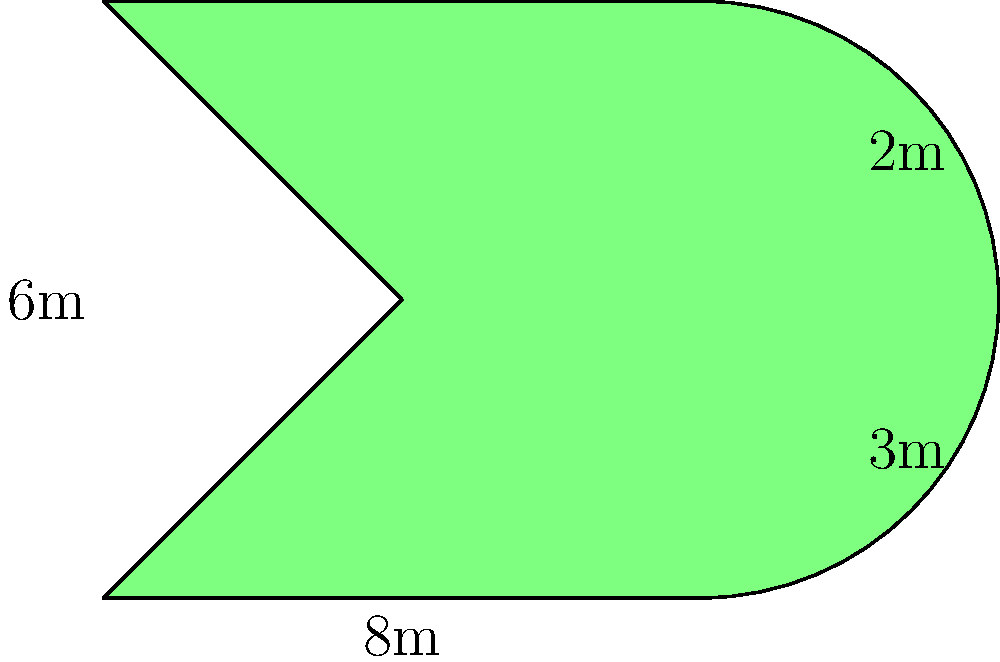The campus landscaping committee has decided to create a guitar-shaped garden to honor the music department. The garden's shape can be approximated by a rectangle with two semicircles on each side, as shown in the diagram. If the length of the rectangular part is 8m, its width is 6m, and the radii of the semicircles are 2m and 3m respectively, what is the perimeter of the entire guitar-shaped garden? To find the perimeter of the guitar-shaped garden, we need to calculate the length of the outer edge:

1. Calculate the perimeter of the rectangular part:
   $$2 \times (8m + 6m) = 28m$$

2. Calculate the length of the semicircle with radius 2m:
   $$\frac{1}{2} \times 2\pi r = \frac{1}{2} \times 2\pi \times 2m = 2\pi m$$

3. Calculate the length of the semicircle with radius 3m:
   $$\frac{1}{2} \times 2\pi r = \frac{1}{2} \times 2\pi \times 3m = 3\pi m$$

4. Sum up all parts:
   $$28m + 2\pi m + 3\pi m = 28m + 5\pi m$$

5. Simplify (if needed):
   $$28 + 5\pi \approx 43.71m$$

Therefore, the perimeter of the guitar-shaped garden is $28 + 5\pi$ meters or approximately 43.71 meters.
Answer: $28 + 5\pi$ meters 